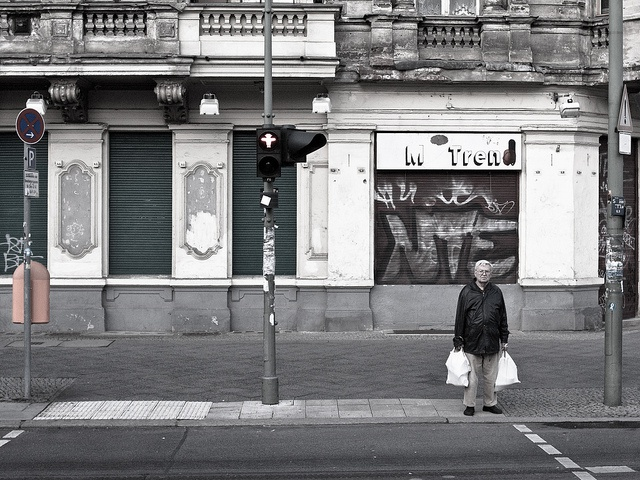Describe the objects in this image and their specific colors. I can see people in darkgray, black, gray, and lightgray tones and traffic light in darkgray, black, gray, white, and maroon tones in this image. 